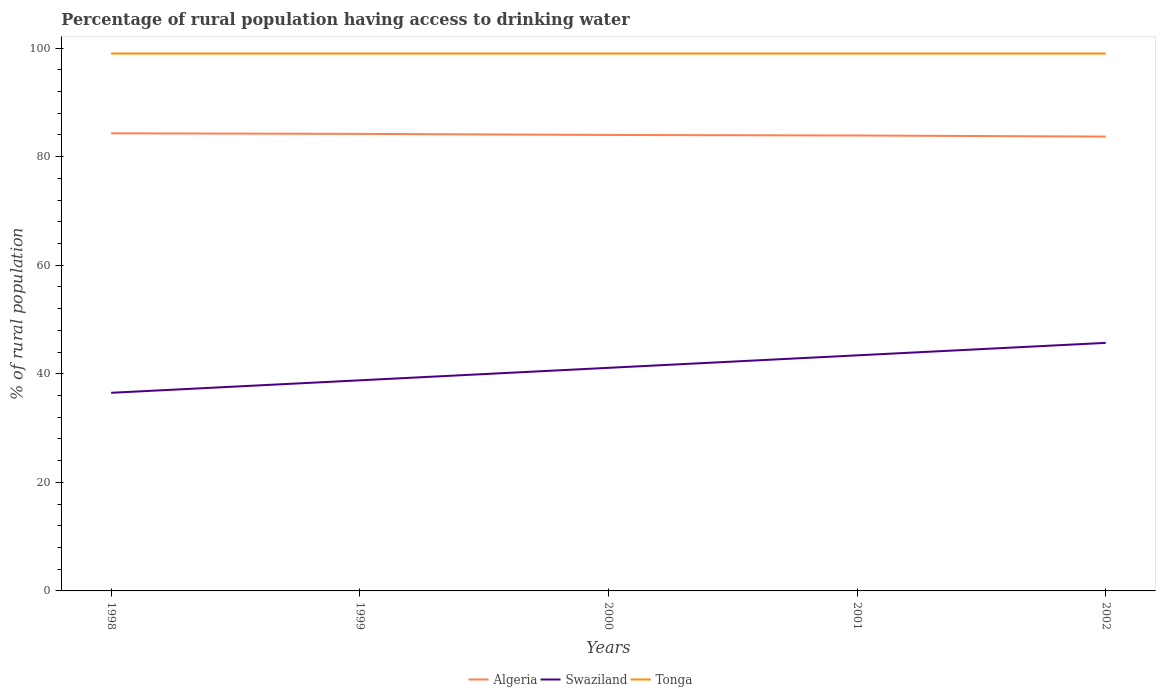How many different coloured lines are there?
Your answer should be compact. 3. Does the line corresponding to Algeria intersect with the line corresponding to Swaziland?
Offer a very short reply. No. Is the number of lines equal to the number of legend labels?
Offer a terse response. Yes. What is the difference between the highest and the lowest percentage of rural population having access to drinking water in Algeria?
Make the answer very short. 2. How many lines are there?
Provide a succinct answer. 3. What is the difference between two consecutive major ticks on the Y-axis?
Offer a terse response. 20. Does the graph contain grids?
Give a very brief answer. No. Where does the legend appear in the graph?
Ensure brevity in your answer.  Bottom center. How are the legend labels stacked?
Your response must be concise. Horizontal. What is the title of the graph?
Offer a very short reply. Percentage of rural population having access to drinking water. What is the label or title of the X-axis?
Your answer should be compact. Years. What is the label or title of the Y-axis?
Your response must be concise. % of rural population. What is the % of rural population of Algeria in 1998?
Provide a short and direct response. 84.3. What is the % of rural population of Swaziland in 1998?
Ensure brevity in your answer.  36.5. What is the % of rural population in Tonga in 1998?
Make the answer very short. 99. What is the % of rural population in Algeria in 1999?
Give a very brief answer. 84.2. What is the % of rural population of Swaziland in 1999?
Your answer should be very brief. 38.8. What is the % of rural population of Tonga in 1999?
Provide a short and direct response. 99. What is the % of rural population of Swaziland in 2000?
Offer a terse response. 41.1. What is the % of rural population in Algeria in 2001?
Make the answer very short. 83.9. What is the % of rural population in Swaziland in 2001?
Your response must be concise. 43.4. What is the % of rural population in Algeria in 2002?
Keep it short and to the point. 83.7. What is the % of rural population in Swaziland in 2002?
Provide a succinct answer. 45.7. What is the % of rural population of Tonga in 2002?
Keep it short and to the point. 99. Across all years, what is the maximum % of rural population in Algeria?
Offer a terse response. 84.3. Across all years, what is the maximum % of rural population in Swaziland?
Offer a terse response. 45.7. Across all years, what is the maximum % of rural population of Tonga?
Your answer should be very brief. 99. Across all years, what is the minimum % of rural population in Algeria?
Offer a very short reply. 83.7. Across all years, what is the minimum % of rural population in Swaziland?
Offer a very short reply. 36.5. What is the total % of rural population of Algeria in the graph?
Give a very brief answer. 420.1. What is the total % of rural population in Swaziland in the graph?
Your answer should be very brief. 205.5. What is the total % of rural population in Tonga in the graph?
Your response must be concise. 495. What is the difference between the % of rural population in Tonga in 1998 and that in 1999?
Ensure brevity in your answer.  0. What is the difference between the % of rural population of Algeria in 1998 and that in 2000?
Give a very brief answer. 0.3. What is the difference between the % of rural population of Algeria in 1999 and that in 2000?
Ensure brevity in your answer.  0.2. What is the difference between the % of rural population of Swaziland in 1999 and that in 2000?
Give a very brief answer. -2.3. What is the difference between the % of rural population in Algeria in 1999 and that in 2001?
Give a very brief answer. 0.3. What is the difference between the % of rural population in Tonga in 1999 and that in 2001?
Provide a succinct answer. 0. What is the difference between the % of rural population in Algeria in 1999 and that in 2002?
Your answer should be very brief. 0.5. What is the difference between the % of rural population in Tonga in 1999 and that in 2002?
Provide a succinct answer. 0. What is the difference between the % of rural population of Swaziland in 2000 and that in 2001?
Your answer should be compact. -2.3. What is the difference between the % of rural population in Algeria in 2000 and that in 2002?
Keep it short and to the point. 0.3. What is the difference between the % of rural population in Tonga in 2000 and that in 2002?
Give a very brief answer. 0. What is the difference between the % of rural population of Tonga in 2001 and that in 2002?
Give a very brief answer. 0. What is the difference between the % of rural population in Algeria in 1998 and the % of rural population in Swaziland in 1999?
Your answer should be compact. 45.5. What is the difference between the % of rural population in Algeria in 1998 and the % of rural population in Tonga in 1999?
Keep it short and to the point. -14.7. What is the difference between the % of rural population of Swaziland in 1998 and the % of rural population of Tonga in 1999?
Your answer should be very brief. -62.5. What is the difference between the % of rural population of Algeria in 1998 and the % of rural population of Swaziland in 2000?
Ensure brevity in your answer.  43.2. What is the difference between the % of rural population in Algeria in 1998 and the % of rural population in Tonga in 2000?
Provide a succinct answer. -14.7. What is the difference between the % of rural population in Swaziland in 1998 and the % of rural population in Tonga in 2000?
Offer a very short reply. -62.5. What is the difference between the % of rural population of Algeria in 1998 and the % of rural population of Swaziland in 2001?
Give a very brief answer. 40.9. What is the difference between the % of rural population of Algeria in 1998 and the % of rural population of Tonga in 2001?
Your answer should be very brief. -14.7. What is the difference between the % of rural population of Swaziland in 1998 and the % of rural population of Tonga in 2001?
Ensure brevity in your answer.  -62.5. What is the difference between the % of rural population of Algeria in 1998 and the % of rural population of Swaziland in 2002?
Keep it short and to the point. 38.6. What is the difference between the % of rural population of Algeria in 1998 and the % of rural population of Tonga in 2002?
Offer a very short reply. -14.7. What is the difference between the % of rural population of Swaziland in 1998 and the % of rural population of Tonga in 2002?
Offer a very short reply. -62.5. What is the difference between the % of rural population in Algeria in 1999 and the % of rural population in Swaziland in 2000?
Provide a succinct answer. 43.1. What is the difference between the % of rural population of Algeria in 1999 and the % of rural population of Tonga in 2000?
Ensure brevity in your answer.  -14.8. What is the difference between the % of rural population of Swaziland in 1999 and the % of rural population of Tonga in 2000?
Your answer should be very brief. -60.2. What is the difference between the % of rural population of Algeria in 1999 and the % of rural population of Swaziland in 2001?
Make the answer very short. 40.8. What is the difference between the % of rural population of Algeria in 1999 and the % of rural population of Tonga in 2001?
Your response must be concise. -14.8. What is the difference between the % of rural population in Swaziland in 1999 and the % of rural population in Tonga in 2001?
Keep it short and to the point. -60.2. What is the difference between the % of rural population of Algeria in 1999 and the % of rural population of Swaziland in 2002?
Provide a short and direct response. 38.5. What is the difference between the % of rural population in Algeria in 1999 and the % of rural population in Tonga in 2002?
Make the answer very short. -14.8. What is the difference between the % of rural population in Swaziland in 1999 and the % of rural population in Tonga in 2002?
Provide a short and direct response. -60.2. What is the difference between the % of rural population in Algeria in 2000 and the % of rural population in Swaziland in 2001?
Keep it short and to the point. 40.6. What is the difference between the % of rural population of Swaziland in 2000 and the % of rural population of Tonga in 2001?
Make the answer very short. -57.9. What is the difference between the % of rural population in Algeria in 2000 and the % of rural population in Swaziland in 2002?
Provide a short and direct response. 38.3. What is the difference between the % of rural population in Algeria in 2000 and the % of rural population in Tonga in 2002?
Give a very brief answer. -15. What is the difference between the % of rural population in Swaziland in 2000 and the % of rural population in Tonga in 2002?
Make the answer very short. -57.9. What is the difference between the % of rural population of Algeria in 2001 and the % of rural population of Swaziland in 2002?
Keep it short and to the point. 38.2. What is the difference between the % of rural population in Algeria in 2001 and the % of rural population in Tonga in 2002?
Keep it short and to the point. -15.1. What is the difference between the % of rural population of Swaziland in 2001 and the % of rural population of Tonga in 2002?
Your answer should be very brief. -55.6. What is the average % of rural population of Algeria per year?
Keep it short and to the point. 84.02. What is the average % of rural population of Swaziland per year?
Offer a terse response. 41.1. What is the average % of rural population in Tonga per year?
Offer a very short reply. 99. In the year 1998, what is the difference between the % of rural population of Algeria and % of rural population of Swaziland?
Provide a short and direct response. 47.8. In the year 1998, what is the difference between the % of rural population in Algeria and % of rural population in Tonga?
Keep it short and to the point. -14.7. In the year 1998, what is the difference between the % of rural population of Swaziland and % of rural population of Tonga?
Offer a terse response. -62.5. In the year 1999, what is the difference between the % of rural population of Algeria and % of rural population of Swaziland?
Your answer should be very brief. 45.4. In the year 1999, what is the difference between the % of rural population in Algeria and % of rural population in Tonga?
Your response must be concise. -14.8. In the year 1999, what is the difference between the % of rural population in Swaziland and % of rural population in Tonga?
Your answer should be compact. -60.2. In the year 2000, what is the difference between the % of rural population in Algeria and % of rural population in Swaziland?
Your answer should be very brief. 42.9. In the year 2000, what is the difference between the % of rural population of Algeria and % of rural population of Tonga?
Provide a short and direct response. -15. In the year 2000, what is the difference between the % of rural population of Swaziland and % of rural population of Tonga?
Provide a succinct answer. -57.9. In the year 2001, what is the difference between the % of rural population in Algeria and % of rural population in Swaziland?
Offer a terse response. 40.5. In the year 2001, what is the difference between the % of rural population in Algeria and % of rural population in Tonga?
Provide a short and direct response. -15.1. In the year 2001, what is the difference between the % of rural population of Swaziland and % of rural population of Tonga?
Your answer should be compact. -55.6. In the year 2002, what is the difference between the % of rural population in Algeria and % of rural population in Swaziland?
Give a very brief answer. 38. In the year 2002, what is the difference between the % of rural population in Algeria and % of rural population in Tonga?
Ensure brevity in your answer.  -15.3. In the year 2002, what is the difference between the % of rural population of Swaziland and % of rural population of Tonga?
Ensure brevity in your answer.  -53.3. What is the ratio of the % of rural population of Swaziland in 1998 to that in 1999?
Offer a terse response. 0.94. What is the ratio of the % of rural population of Tonga in 1998 to that in 1999?
Make the answer very short. 1. What is the ratio of the % of rural population of Swaziland in 1998 to that in 2000?
Provide a succinct answer. 0.89. What is the ratio of the % of rural population in Algeria in 1998 to that in 2001?
Give a very brief answer. 1. What is the ratio of the % of rural population of Swaziland in 1998 to that in 2001?
Offer a very short reply. 0.84. What is the ratio of the % of rural population in Algeria in 1998 to that in 2002?
Offer a terse response. 1.01. What is the ratio of the % of rural population in Swaziland in 1998 to that in 2002?
Offer a terse response. 0.8. What is the ratio of the % of rural population of Tonga in 1998 to that in 2002?
Give a very brief answer. 1. What is the ratio of the % of rural population in Algeria in 1999 to that in 2000?
Make the answer very short. 1. What is the ratio of the % of rural population in Swaziland in 1999 to that in 2000?
Your response must be concise. 0.94. What is the ratio of the % of rural population of Tonga in 1999 to that in 2000?
Provide a short and direct response. 1. What is the ratio of the % of rural population in Swaziland in 1999 to that in 2001?
Provide a succinct answer. 0.89. What is the ratio of the % of rural population of Algeria in 1999 to that in 2002?
Your answer should be very brief. 1.01. What is the ratio of the % of rural population of Swaziland in 1999 to that in 2002?
Your response must be concise. 0.85. What is the ratio of the % of rural population in Swaziland in 2000 to that in 2001?
Your answer should be very brief. 0.95. What is the ratio of the % of rural population in Tonga in 2000 to that in 2001?
Ensure brevity in your answer.  1. What is the ratio of the % of rural population of Algeria in 2000 to that in 2002?
Give a very brief answer. 1. What is the ratio of the % of rural population of Swaziland in 2000 to that in 2002?
Your answer should be compact. 0.9. What is the ratio of the % of rural population in Swaziland in 2001 to that in 2002?
Provide a short and direct response. 0.95. 